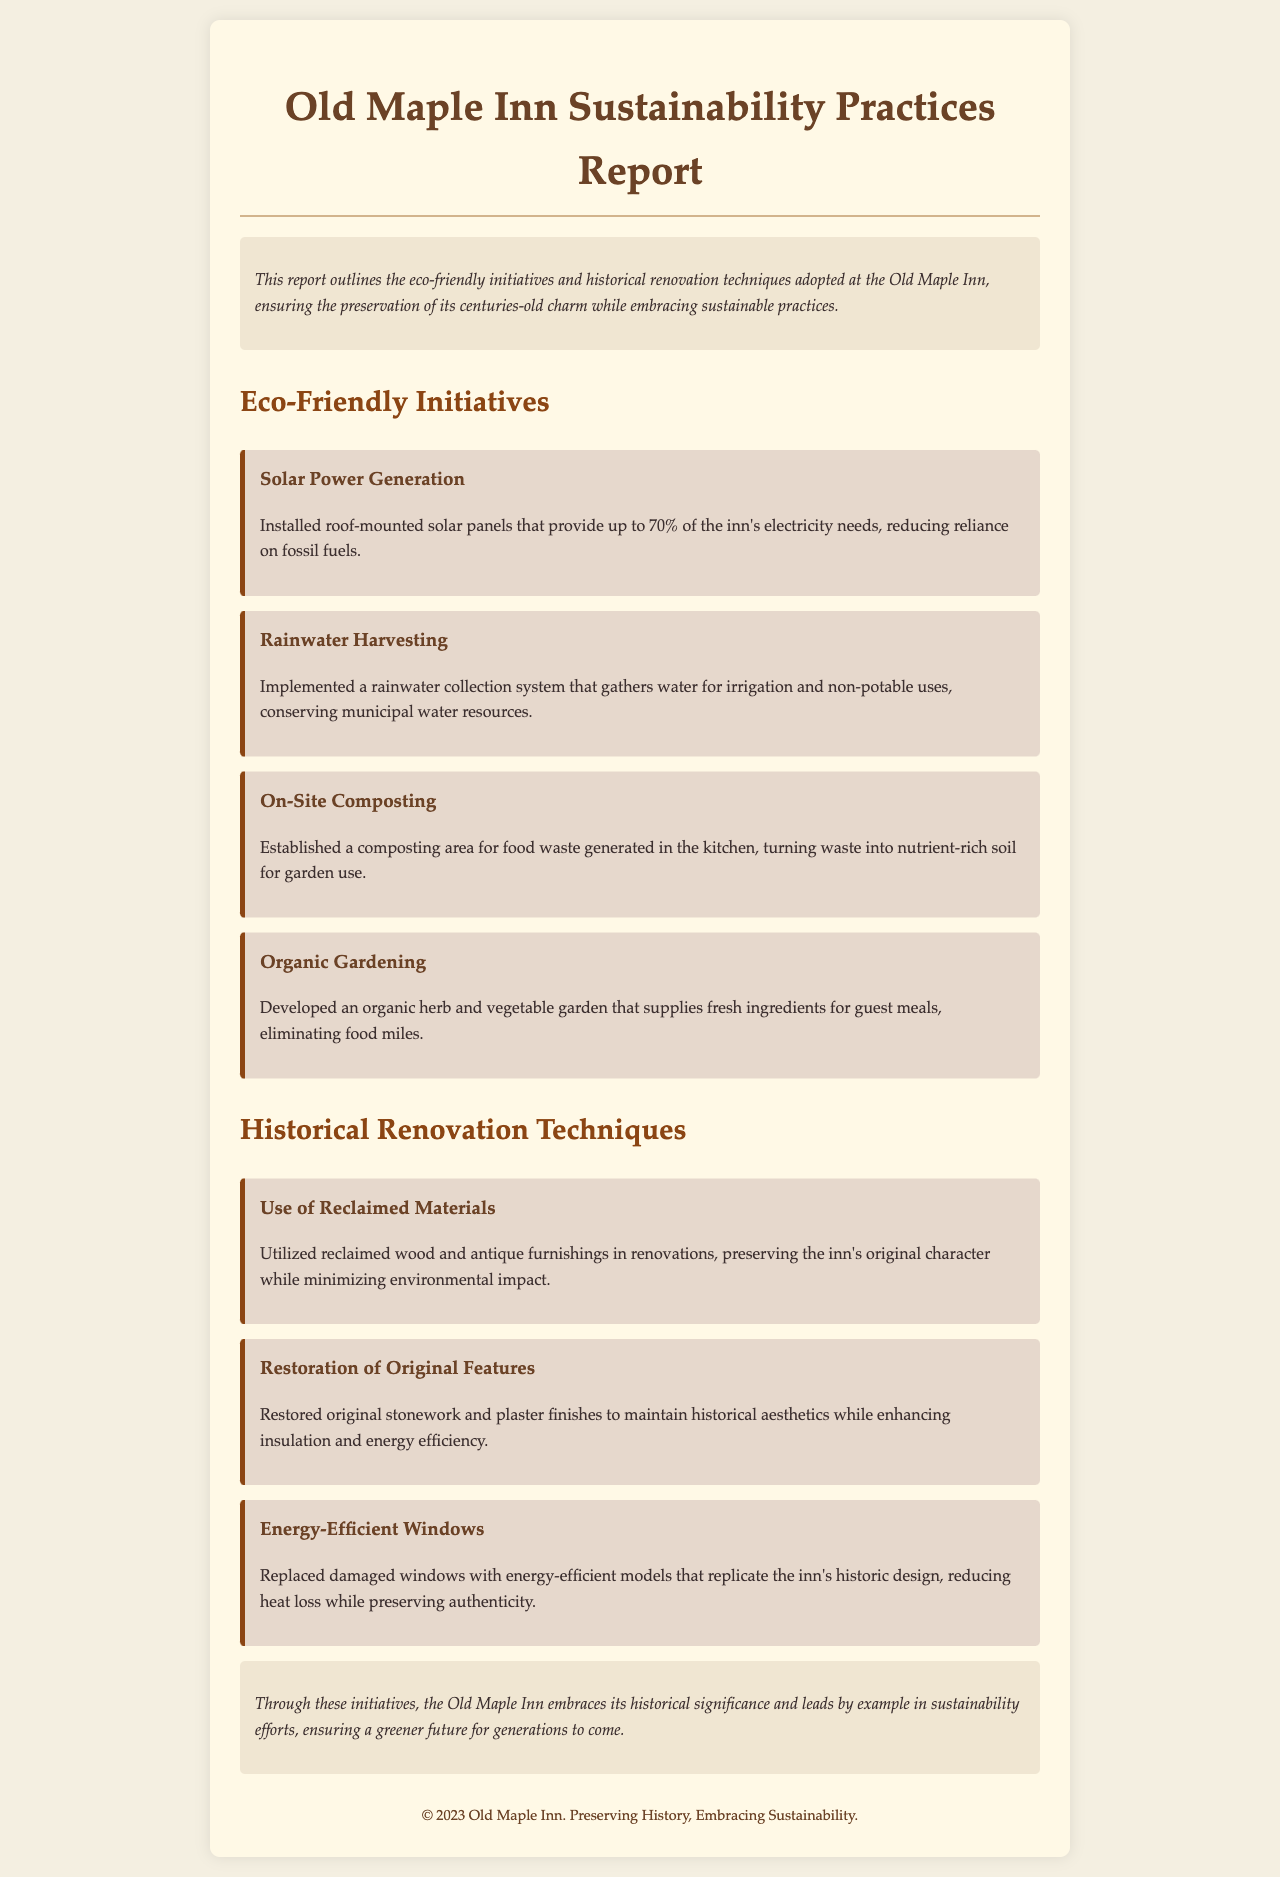What is the primary energy source for the Old Maple Inn? The primary energy source for the Old Maple Inn is solar power, as stated in the initiative about solar power generation.
Answer: Solar power How much of the inn's electricity needs are met by solar panels? The document mentions that the solar panels provide up to 70% of the inn's electricity needs.
Answer: 70% What system was implemented to conserve municipal water resources? The document states that a rainwater collection system was implemented for irrigation and non-potable uses.
Answer: Rainwater collection system What type of gardening has been developed on-site? The document specifies that an organic herb and vegetable garden has been developed for guest meals.
Answer: Organic gardening What materials were utilized in renovations to minimize environmental impact? The document indicates that reclaimed wood and antique furnishings were used in renovations to preserve character and minimize impact.
Answer: Reclaimed materials What feature was restored to enhance insulation while maintaining aesthetics? The original stonework and plaster finishes were restored to enhance insulation and energy efficiency.
Answer: Original stonework and plaster finishes What type of windows were replaced to reduce heat loss? The document mentions that damaged windows were replaced with energy-efficient models.
Answer: Energy-efficient windows What is the overall purpose of the sustainability initiatives at the Old Maple Inn? The document concludes that the initiatives embrace historical significance and support sustainability efforts for the future.
Answer: Embrace historical significance and support sustainability How does the inn's approach affect future generations? The report concludes that the inn is ensuring a greener future for generations to come through its initiatives.
Answer: Ensuring a greener future 